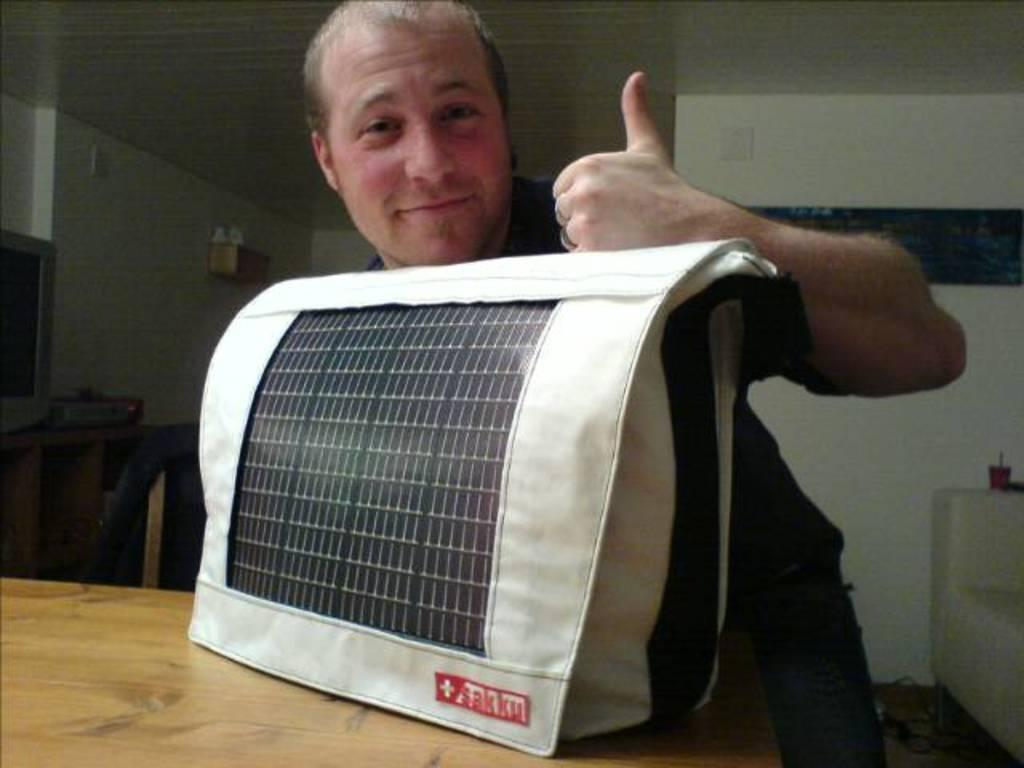Who is present in the image? There is a man in the image. What is the man's facial expression? The man is smiling. What object can be seen on the table in the image? There is a bag on the table. What type of structure is visible in the image? There is a wall visible in the image. What is the man's name in the image? The provided facts do not mention the man's name, so we cannot determine it from the image. 